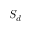Convert formula to latex. <formula><loc_0><loc_0><loc_500><loc_500>S _ { d }</formula> 